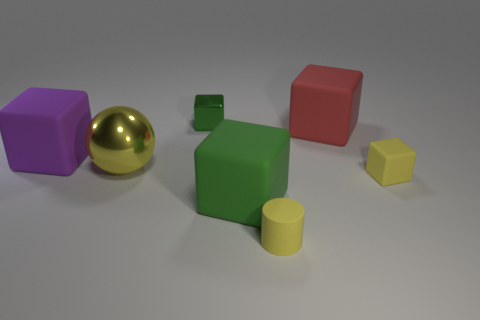What shape is the purple matte thing that is the same size as the yellow metal thing?
Ensure brevity in your answer.  Cube. What number of other objects are there of the same color as the shiny sphere?
Your response must be concise. 2. How many other objects are the same material as the large red thing?
Your response must be concise. 4. There is a purple rubber cube; is its size the same as the green object that is in front of the large yellow thing?
Provide a succinct answer. Yes. The cylinder has what color?
Offer a very short reply. Yellow. There is a yellow thing in front of the rubber block in front of the rubber block that is right of the large red matte thing; what is its shape?
Provide a short and direct response. Cylinder. There is a small block to the right of the small object on the left side of the yellow cylinder; what is it made of?
Keep it short and to the point. Rubber. The red object that is the same material as the large green object is what shape?
Your answer should be very brief. Cube. Is there any other thing that has the same shape as the large green thing?
Ensure brevity in your answer.  Yes. What number of metallic objects are right of the big yellow metal ball?
Provide a succinct answer. 1. 